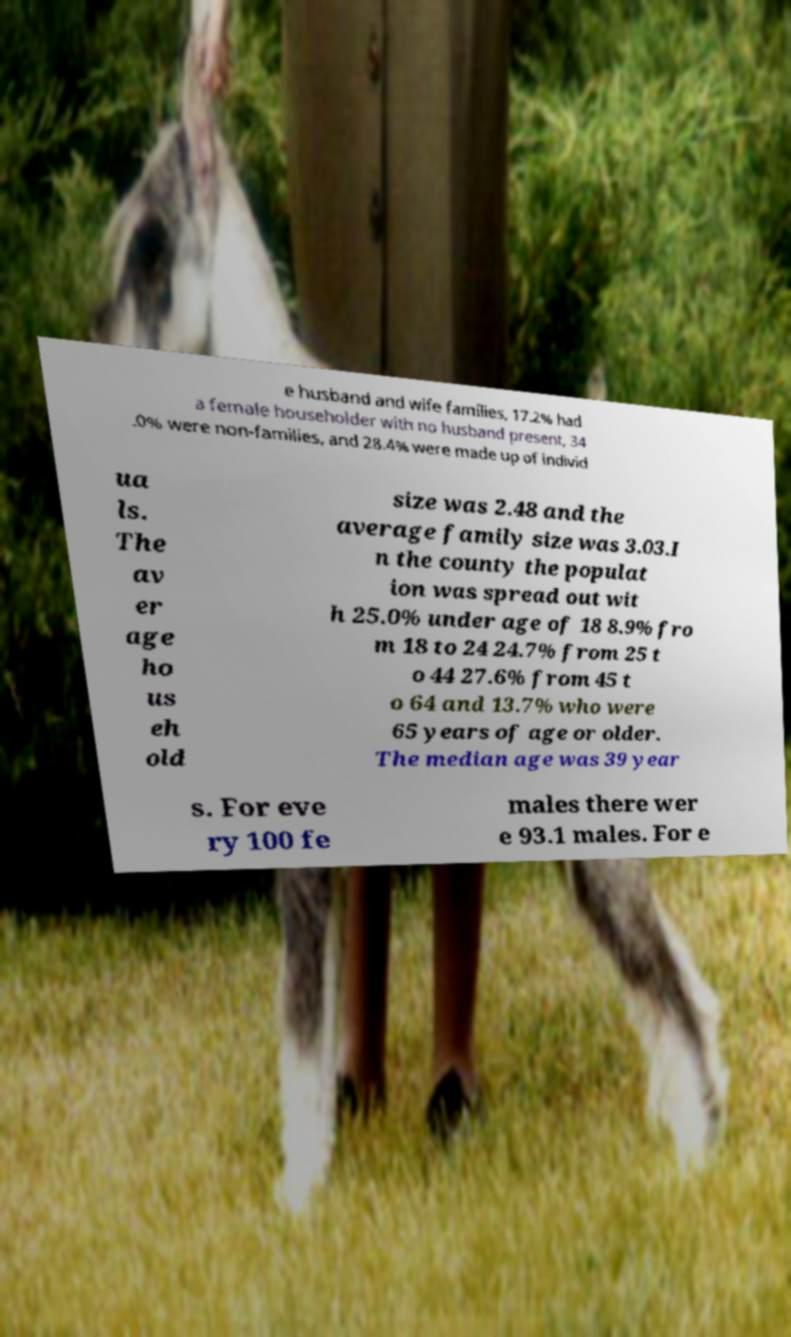Could you assist in decoding the text presented in this image and type it out clearly? e husband and wife families, 17.2% had a female householder with no husband present, 34 .0% were non-families, and 28.4% were made up of individ ua ls. The av er age ho us eh old size was 2.48 and the average family size was 3.03.I n the county the populat ion was spread out wit h 25.0% under age of 18 8.9% fro m 18 to 24 24.7% from 25 t o 44 27.6% from 45 t o 64 and 13.7% who were 65 years of age or older. The median age was 39 year s. For eve ry 100 fe males there wer e 93.1 males. For e 